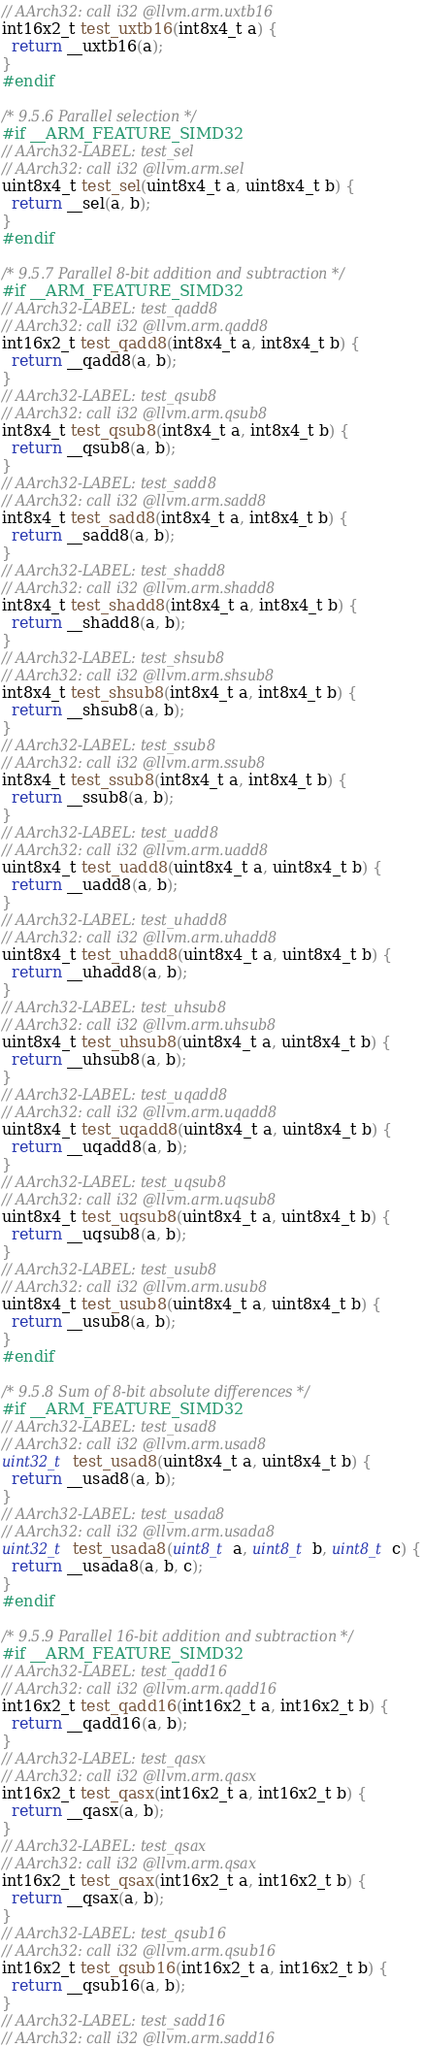<code> <loc_0><loc_0><loc_500><loc_500><_C_>// AArch32: call i32 @llvm.arm.uxtb16
int16x2_t test_uxtb16(int8x4_t a) {
  return __uxtb16(a);
}
#endif

/* 9.5.6 Parallel selection */
#if __ARM_FEATURE_SIMD32
// AArch32-LABEL: test_sel
// AArch32: call i32 @llvm.arm.sel
uint8x4_t test_sel(uint8x4_t a, uint8x4_t b) {
  return __sel(a, b);
}
#endif

/* 9.5.7 Parallel 8-bit addition and subtraction */
#if __ARM_FEATURE_SIMD32
// AArch32-LABEL: test_qadd8
// AArch32: call i32 @llvm.arm.qadd8
int16x2_t test_qadd8(int8x4_t a, int8x4_t b) {
  return __qadd8(a, b);
}
// AArch32-LABEL: test_qsub8
// AArch32: call i32 @llvm.arm.qsub8
int8x4_t test_qsub8(int8x4_t a, int8x4_t b) {
  return __qsub8(a, b);
}
// AArch32-LABEL: test_sadd8
// AArch32: call i32 @llvm.arm.sadd8
int8x4_t test_sadd8(int8x4_t a, int8x4_t b) {
  return __sadd8(a, b);
}
// AArch32-LABEL: test_shadd8
// AArch32: call i32 @llvm.arm.shadd8
int8x4_t test_shadd8(int8x4_t a, int8x4_t b) {
  return __shadd8(a, b);
}
// AArch32-LABEL: test_shsub8
// AArch32: call i32 @llvm.arm.shsub8
int8x4_t test_shsub8(int8x4_t a, int8x4_t b) {
  return __shsub8(a, b);
}
// AArch32-LABEL: test_ssub8
// AArch32: call i32 @llvm.arm.ssub8
int8x4_t test_ssub8(int8x4_t a, int8x4_t b) {
  return __ssub8(a, b);
}
// AArch32-LABEL: test_uadd8
// AArch32: call i32 @llvm.arm.uadd8
uint8x4_t test_uadd8(uint8x4_t a, uint8x4_t b) {
  return __uadd8(a, b);
}
// AArch32-LABEL: test_uhadd8
// AArch32: call i32 @llvm.arm.uhadd8
uint8x4_t test_uhadd8(uint8x4_t a, uint8x4_t b) {
  return __uhadd8(a, b);
}
// AArch32-LABEL: test_uhsub8
// AArch32: call i32 @llvm.arm.uhsub8
uint8x4_t test_uhsub8(uint8x4_t a, uint8x4_t b) {
  return __uhsub8(a, b);
}
// AArch32-LABEL: test_uqadd8
// AArch32: call i32 @llvm.arm.uqadd8
uint8x4_t test_uqadd8(uint8x4_t a, uint8x4_t b) {
  return __uqadd8(a, b);
}
// AArch32-LABEL: test_uqsub8
// AArch32: call i32 @llvm.arm.uqsub8
uint8x4_t test_uqsub8(uint8x4_t a, uint8x4_t b) {
  return __uqsub8(a, b);
}
// AArch32-LABEL: test_usub8
// AArch32: call i32 @llvm.arm.usub8
uint8x4_t test_usub8(uint8x4_t a, uint8x4_t b) {
  return __usub8(a, b);
}
#endif

/* 9.5.8 Sum of 8-bit absolute differences */
#if __ARM_FEATURE_SIMD32
// AArch32-LABEL: test_usad8
// AArch32: call i32 @llvm.arm.usad8
uint32_t test_usad8(uint8x4_t a, uint8x4_t b) {
  return __usad8(a, b);
}
// AArch32-LABEL: test_usada8
// AArch32: call i32 @llvm.arm.usada8
uint32_t test_usada8(uint8_t a, uint8_t b, uint8_t c) {
  return __usada8(a, b, c);
}
#endif

/* 9.5.9 Parallel 16-bit addition and subtraction */
#if __ARM_FEATURE_SIMD32
// AArch32-LABEL: test_qadd16
// AArch32: call i32 @llvm.arm.qadd16
int16x2_t test_qadd16(int16x2_t a, int16x2_t b) {
  return __qadd16(a, b);
}
// AArch32-LABEL: test_qasx
// AArch32: call i32 @llvm.arm.qasx
int16x2_t test_qasx(int16x2_t a, int16x2_t b) {
  return __qasx(a, b);
}
// AArch32-LABEL: test_qsax
// AArch32: call i32 @llvm.arm.qsax
int16x2_t test_qsax(int16x2_t a, int16x2_t b) {
  return __qsax(a, b);
}
// AArch32-LABEL: test_qsub16
// AArch32: call i32 @llvm.arm.qsub16
int16x2_t test_qsub16(int16x2_t a, int16x2_t b) {
  return __qsub16(a, b);
}
// AArch32-LABEL: test_sadd16
// AArch32: call i32 @llvm.arm.sadd16</code> 